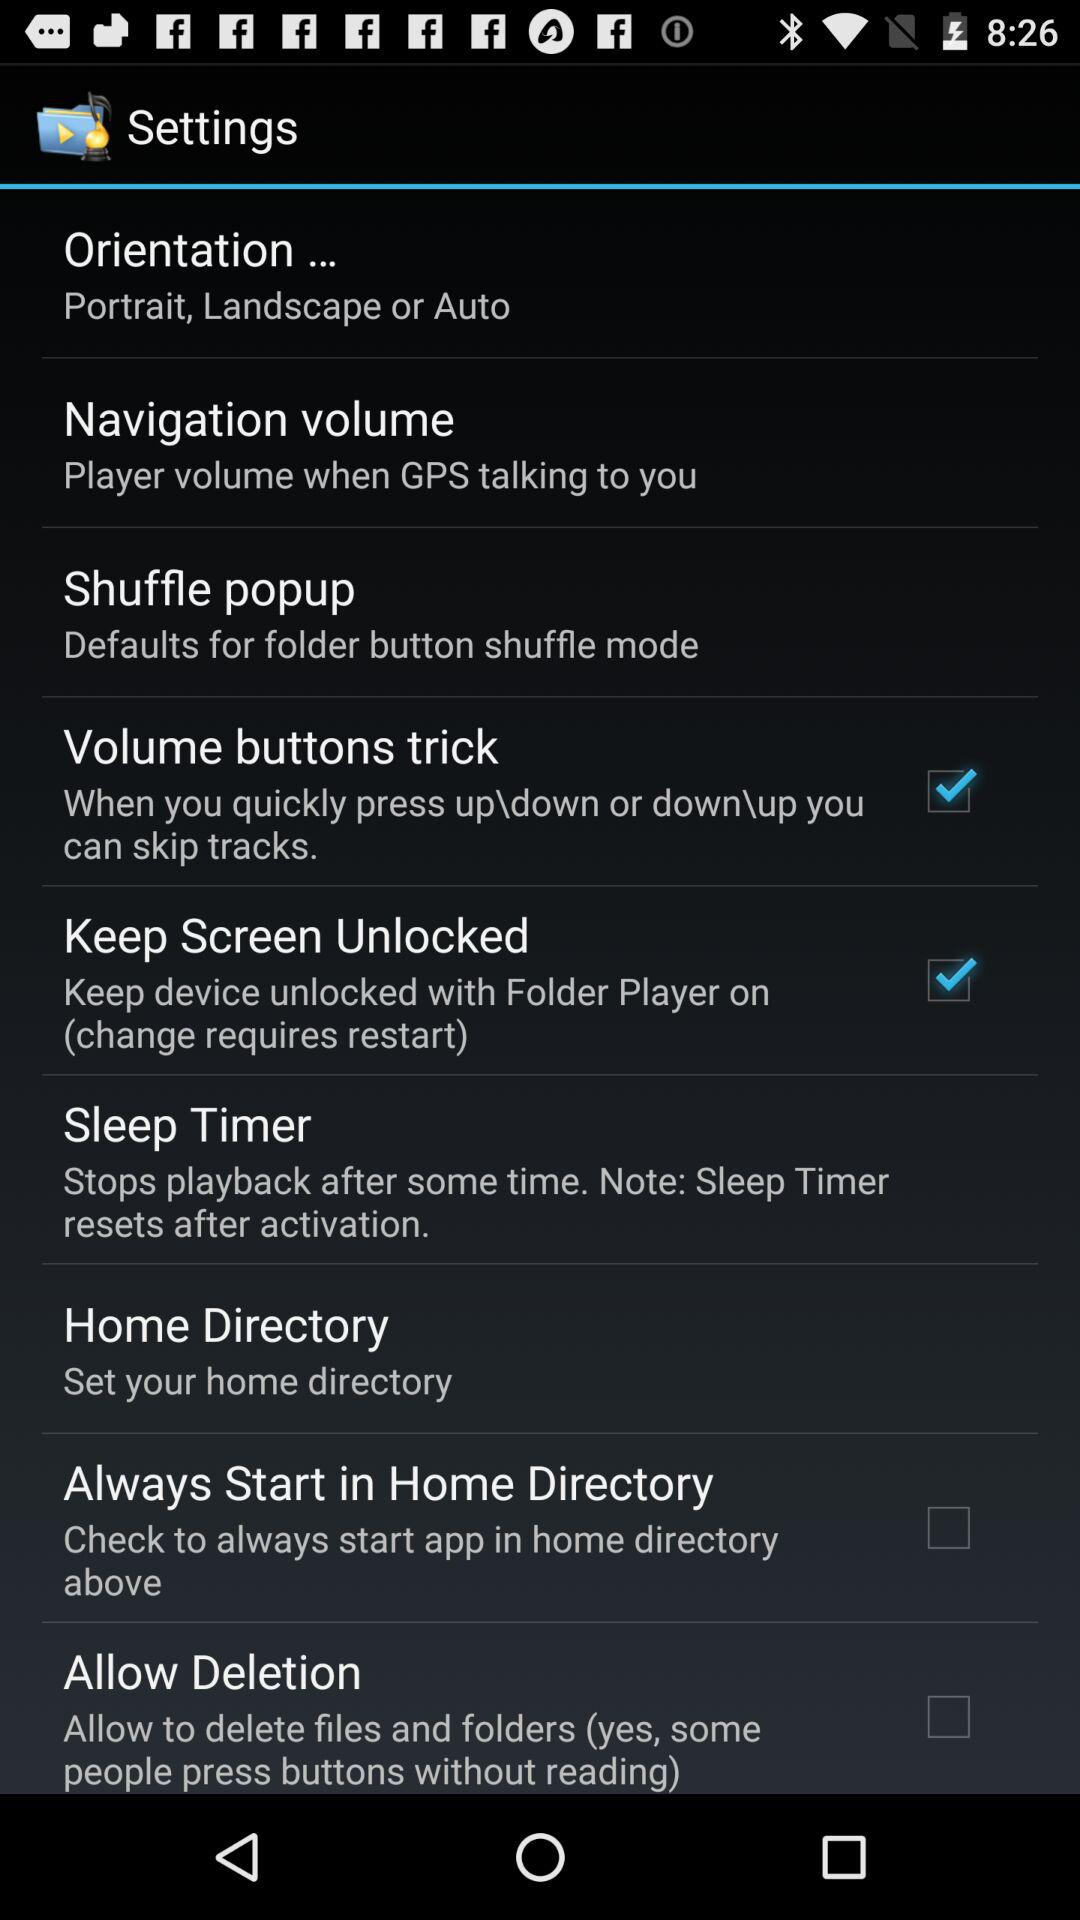What is the status of "Allow Deletion"? The status is "off". 